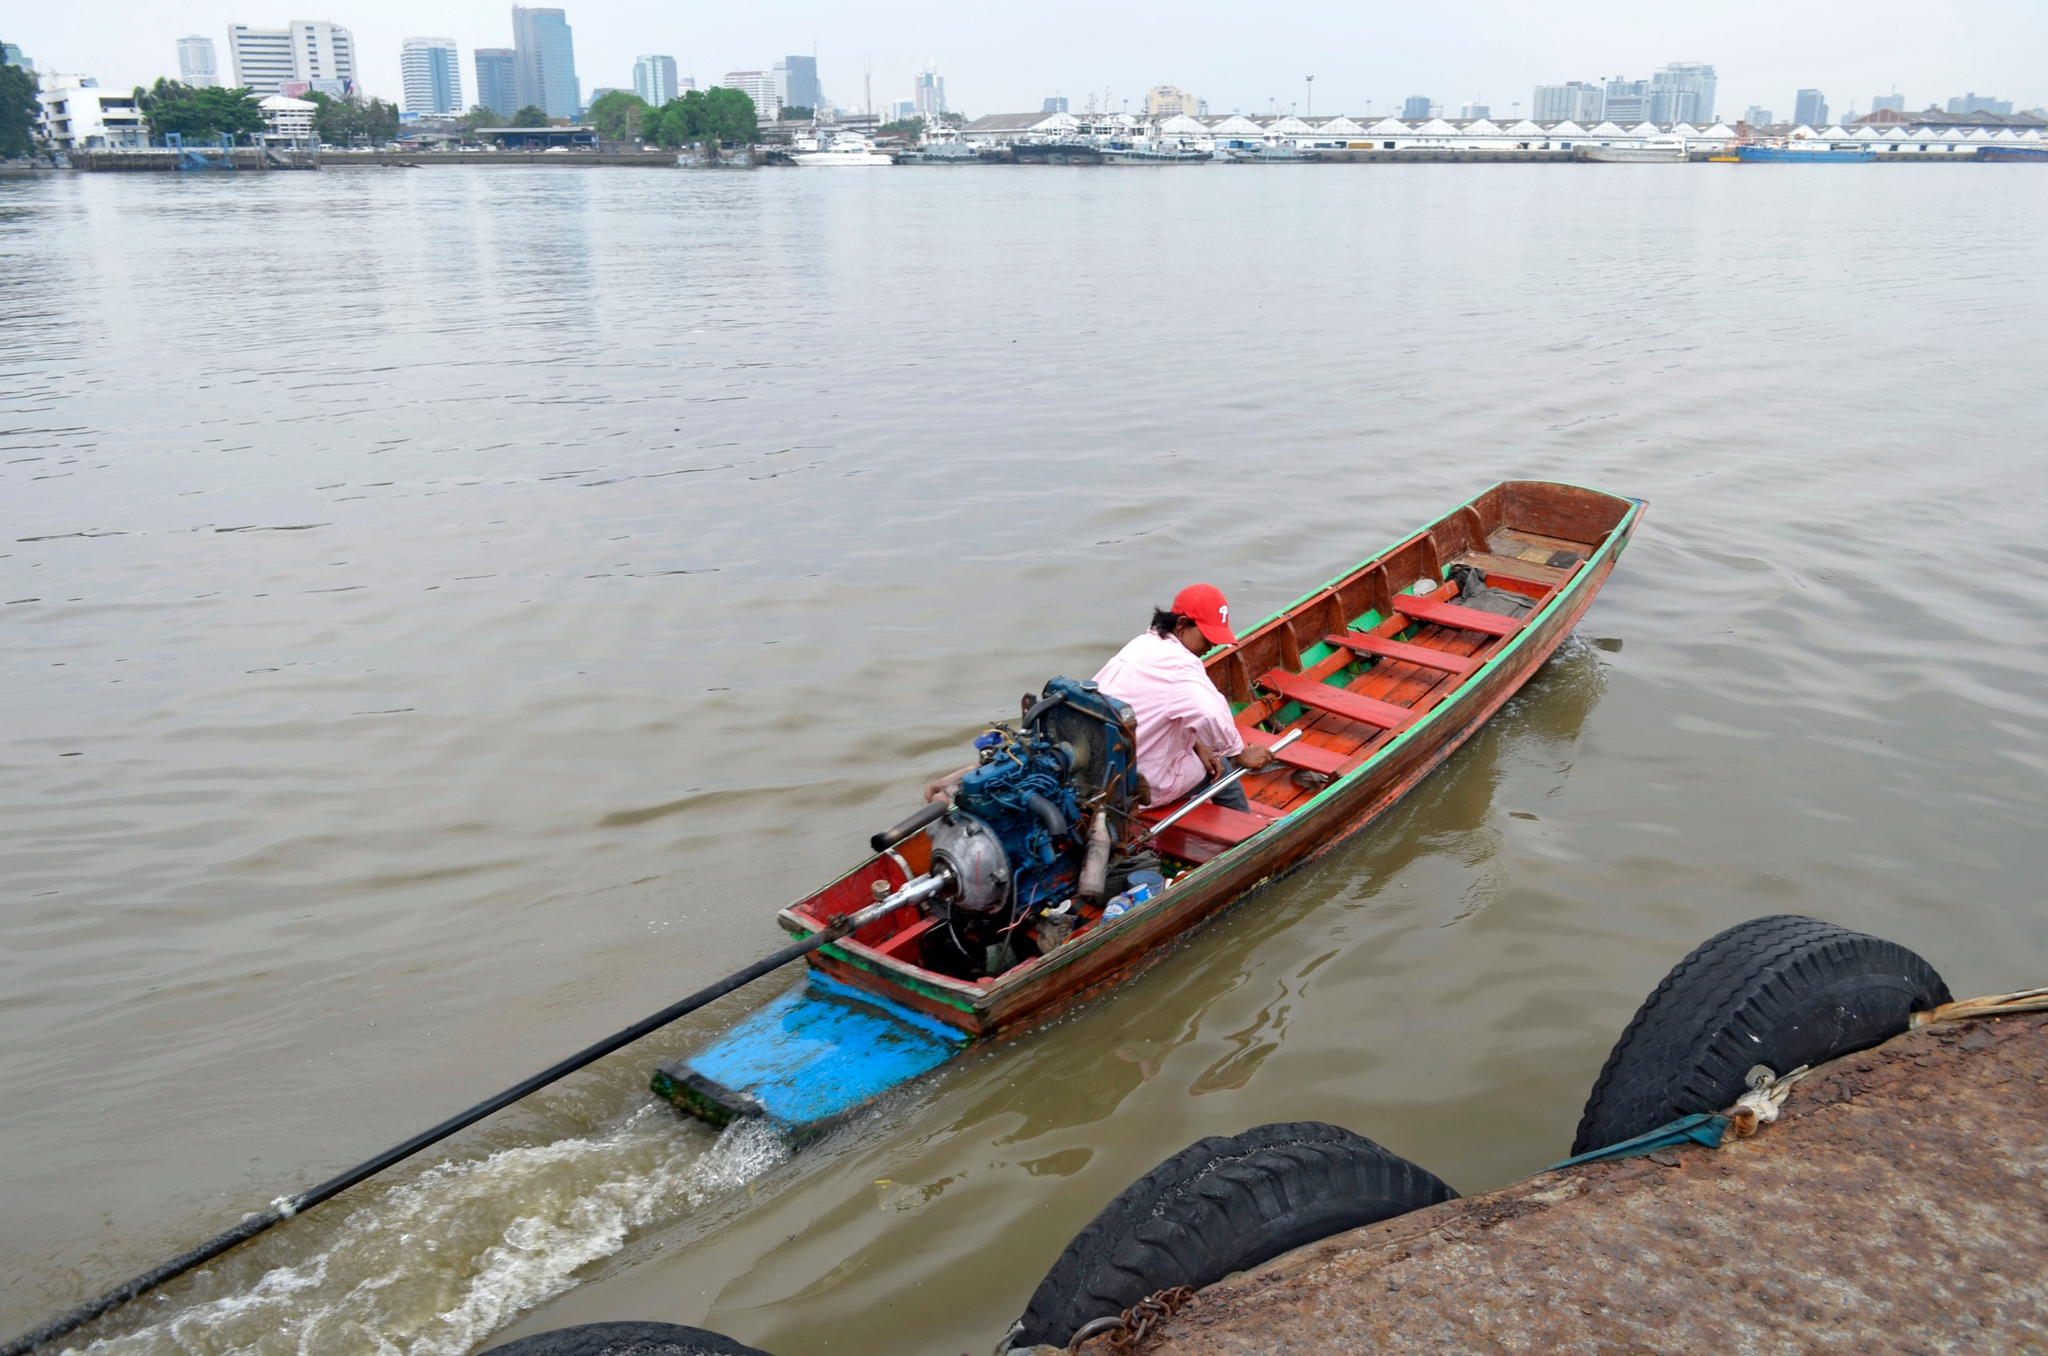Describe a possible conversation the person in the boat might be having with someone onshore. Person in the Boat: 'Hey there! The current is pretty gentle today, perfect for a low-key boat ride. How’s everything onshore?'

Person onshore: 'All’s good here! Looks like you’re having a peaceful ride. How’s the view from out there?'

Person in the Boat: 'It’s beautiful! The skyline looks almost magical with the overcast sky. It’s a nice escape from the hustle and bustle.'

Person onshore: 'Sounds wonderful. I could use a break myself. Maybe I’ll join you next time!' 